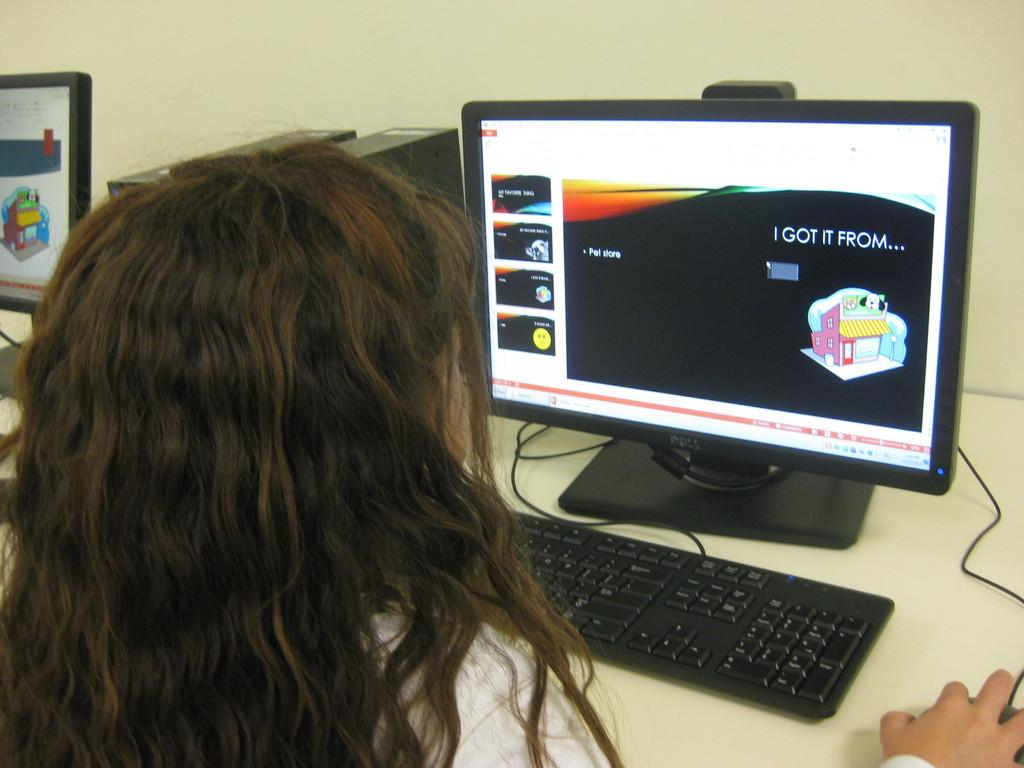<image>
Summarize the visual content of the image. a girl is using a computer with a screen that says I got it from.... 